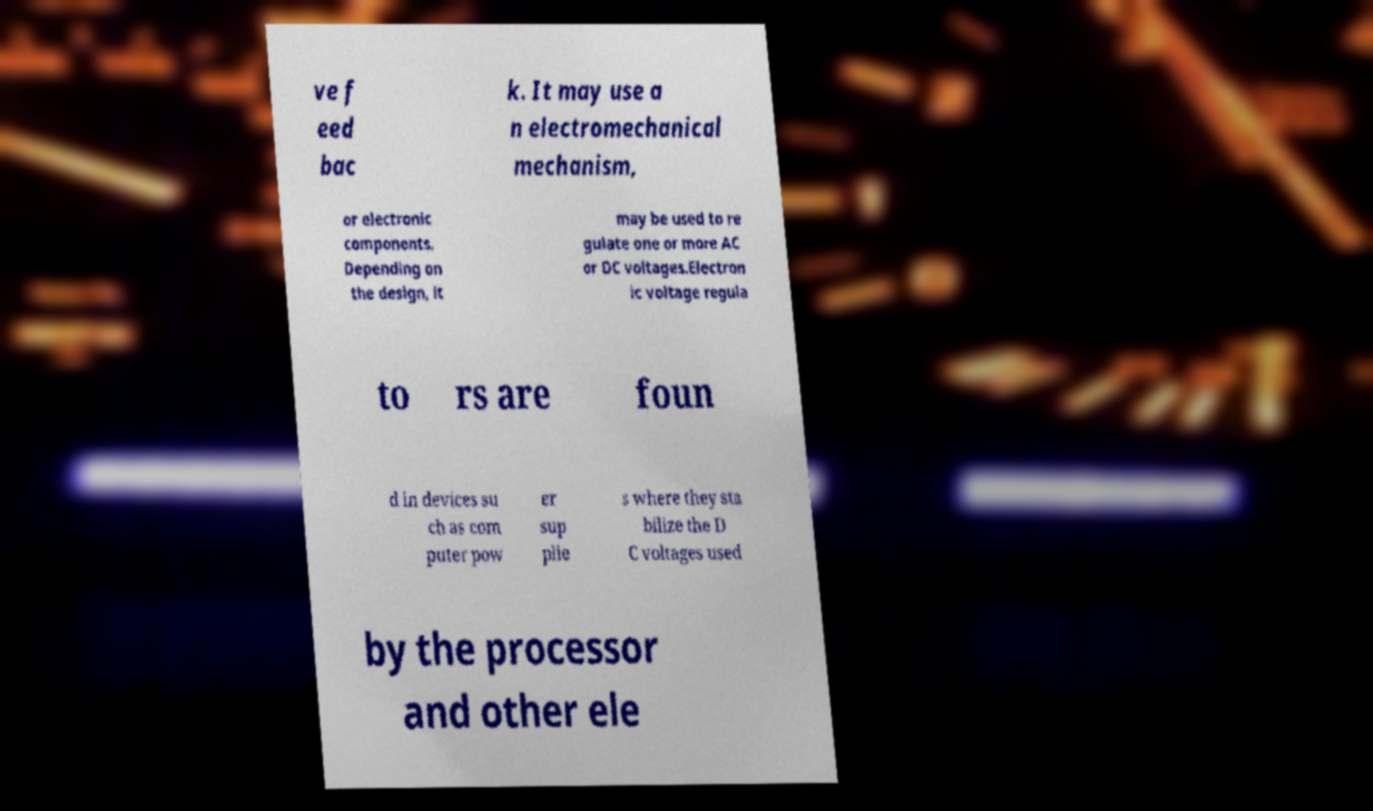Can you read and provide the text displayed in the image?This photo seems to have some interesting text. Can you extract and type it out for me? ve f eed bac k. It may use a n electromechanical mechanism, or electronic components. Depending on the design, it may be used to re gulate one or more AC or DC voltages.Electron ic voltage regula to rs are foun d in devices su ch as com puter pow er sup plie s where they sta bilize the D C voltages used by the processor and other ele 